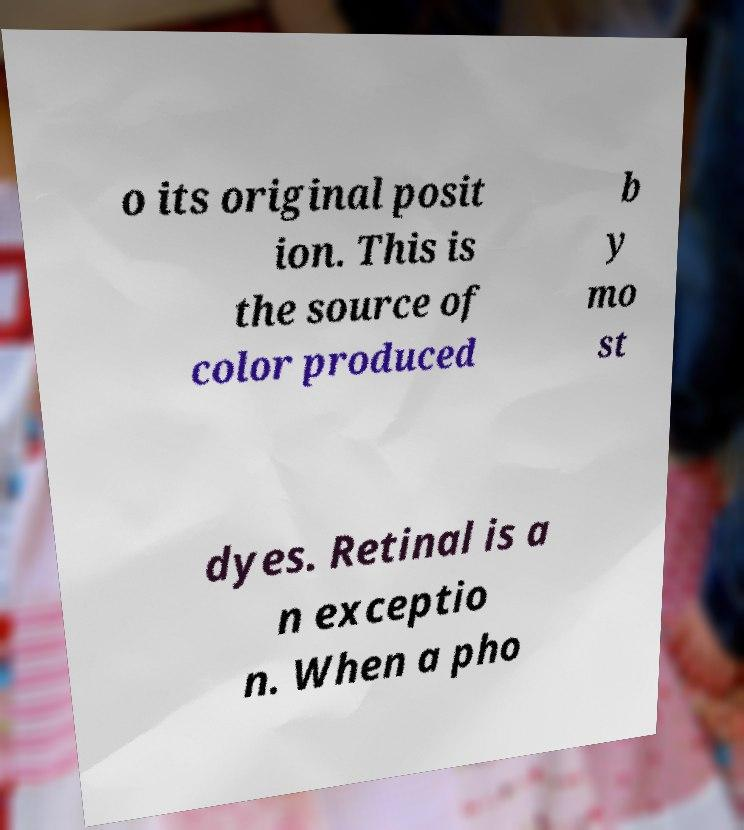There's text embedded in this image that I need extracted. Can you transcribe it verbatim? o its original posit ion. This is the source of color produced b y mo st dyes. Retinal is a n exceptio n. When a pho 